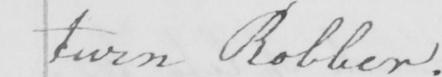What text is written in this handwritten line? turn Robber . 